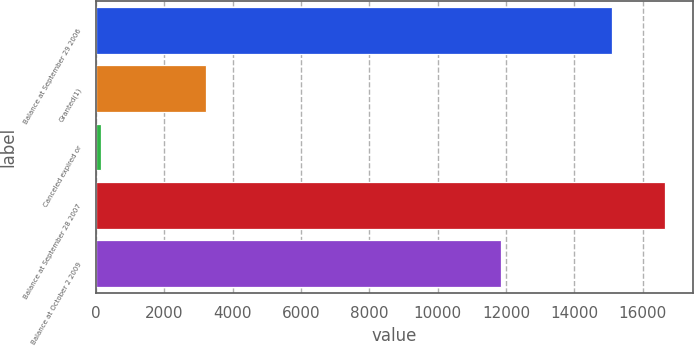Convert chart to OTSL. <chart><loc_0><loc_0><loc_500><loc_500><bar_chart><fcel>Balance at September 29 2006<fcel>Granted(1)<fcel>Canceled expired or<fcel>Balance at September 28 2007<fcel>Balance at October 2 2009<nl><fcel>15111<fcel>3233.8<fcel>146<fcel>16654.9<fcel>11853<nl></chart> 